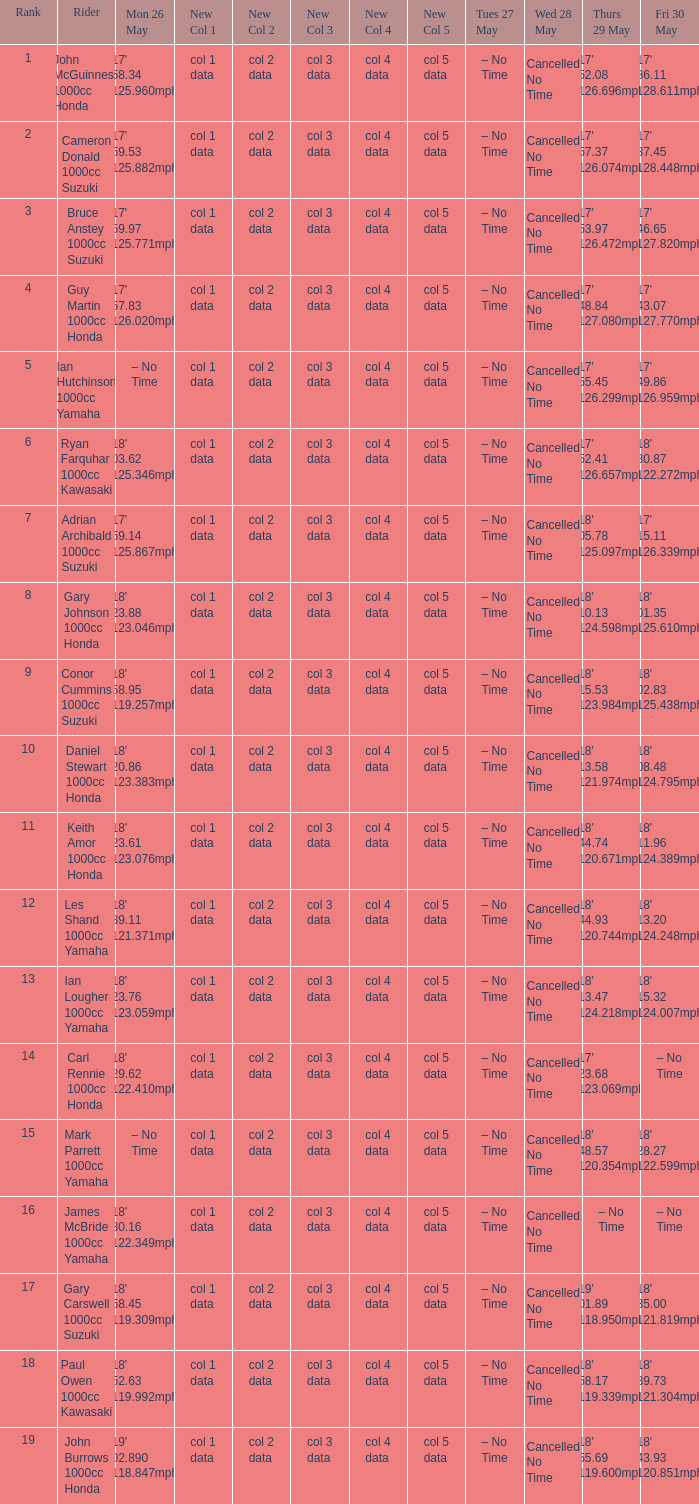What tims is wed may 28 and mon may 26 is 17' 58.34 125.960mph? Cancelled No Time. 